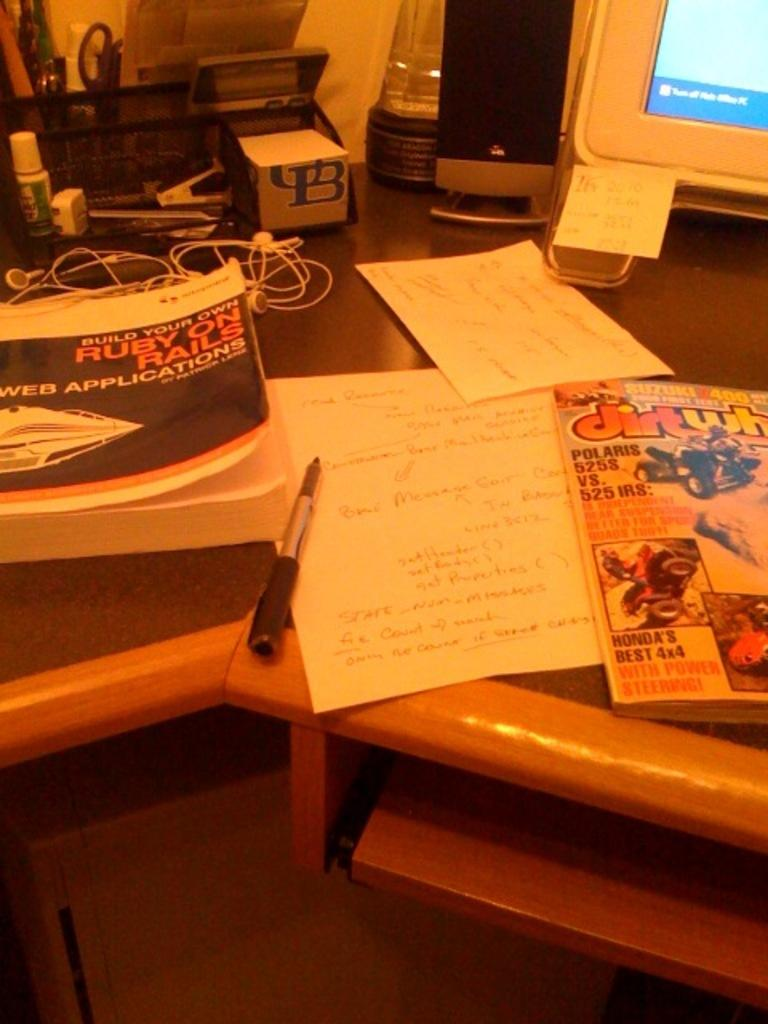What type of furniture is present in the image? There is a table in the image. What is located under the table? There is a box under the table. What items can be seen on the table? There are papers, books, a pen, a wire, a bottle, a speaker, and a monitor on the table. Are there any other objects on the table besides the ones mentioned? Yes, there are other objects on the table. What type of weather can be seen in the image? There is no weather depicted in the image, as it is an indoor scene with a table and various objects. Can you tell me how many friends are present in the image? There is no mention of friends or people in the image; it only shows a table with various objects on it. 